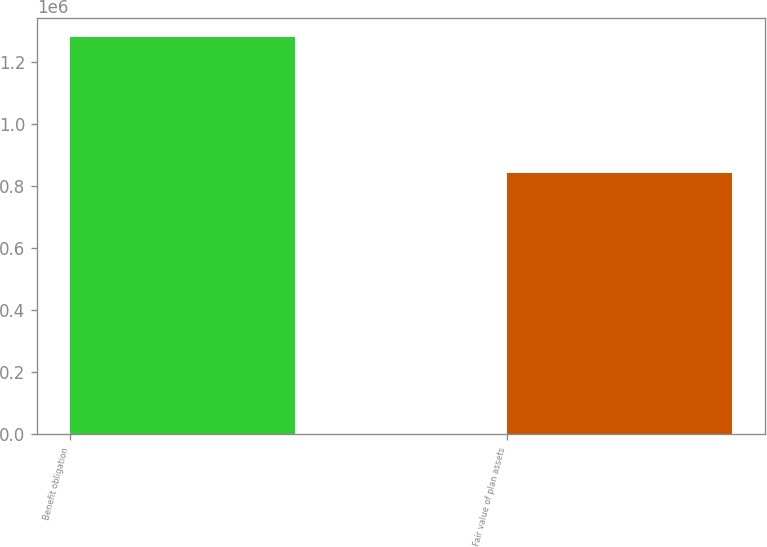Convert chart to OTSL. <chart><loc_0><loc_0><loc_500><loc_500><bar_chart><fcel>Benefit obligation<fcel>Fair value of plan assets<nl><fcel>1.27772e+06<fcel>842168<nl></chart> 